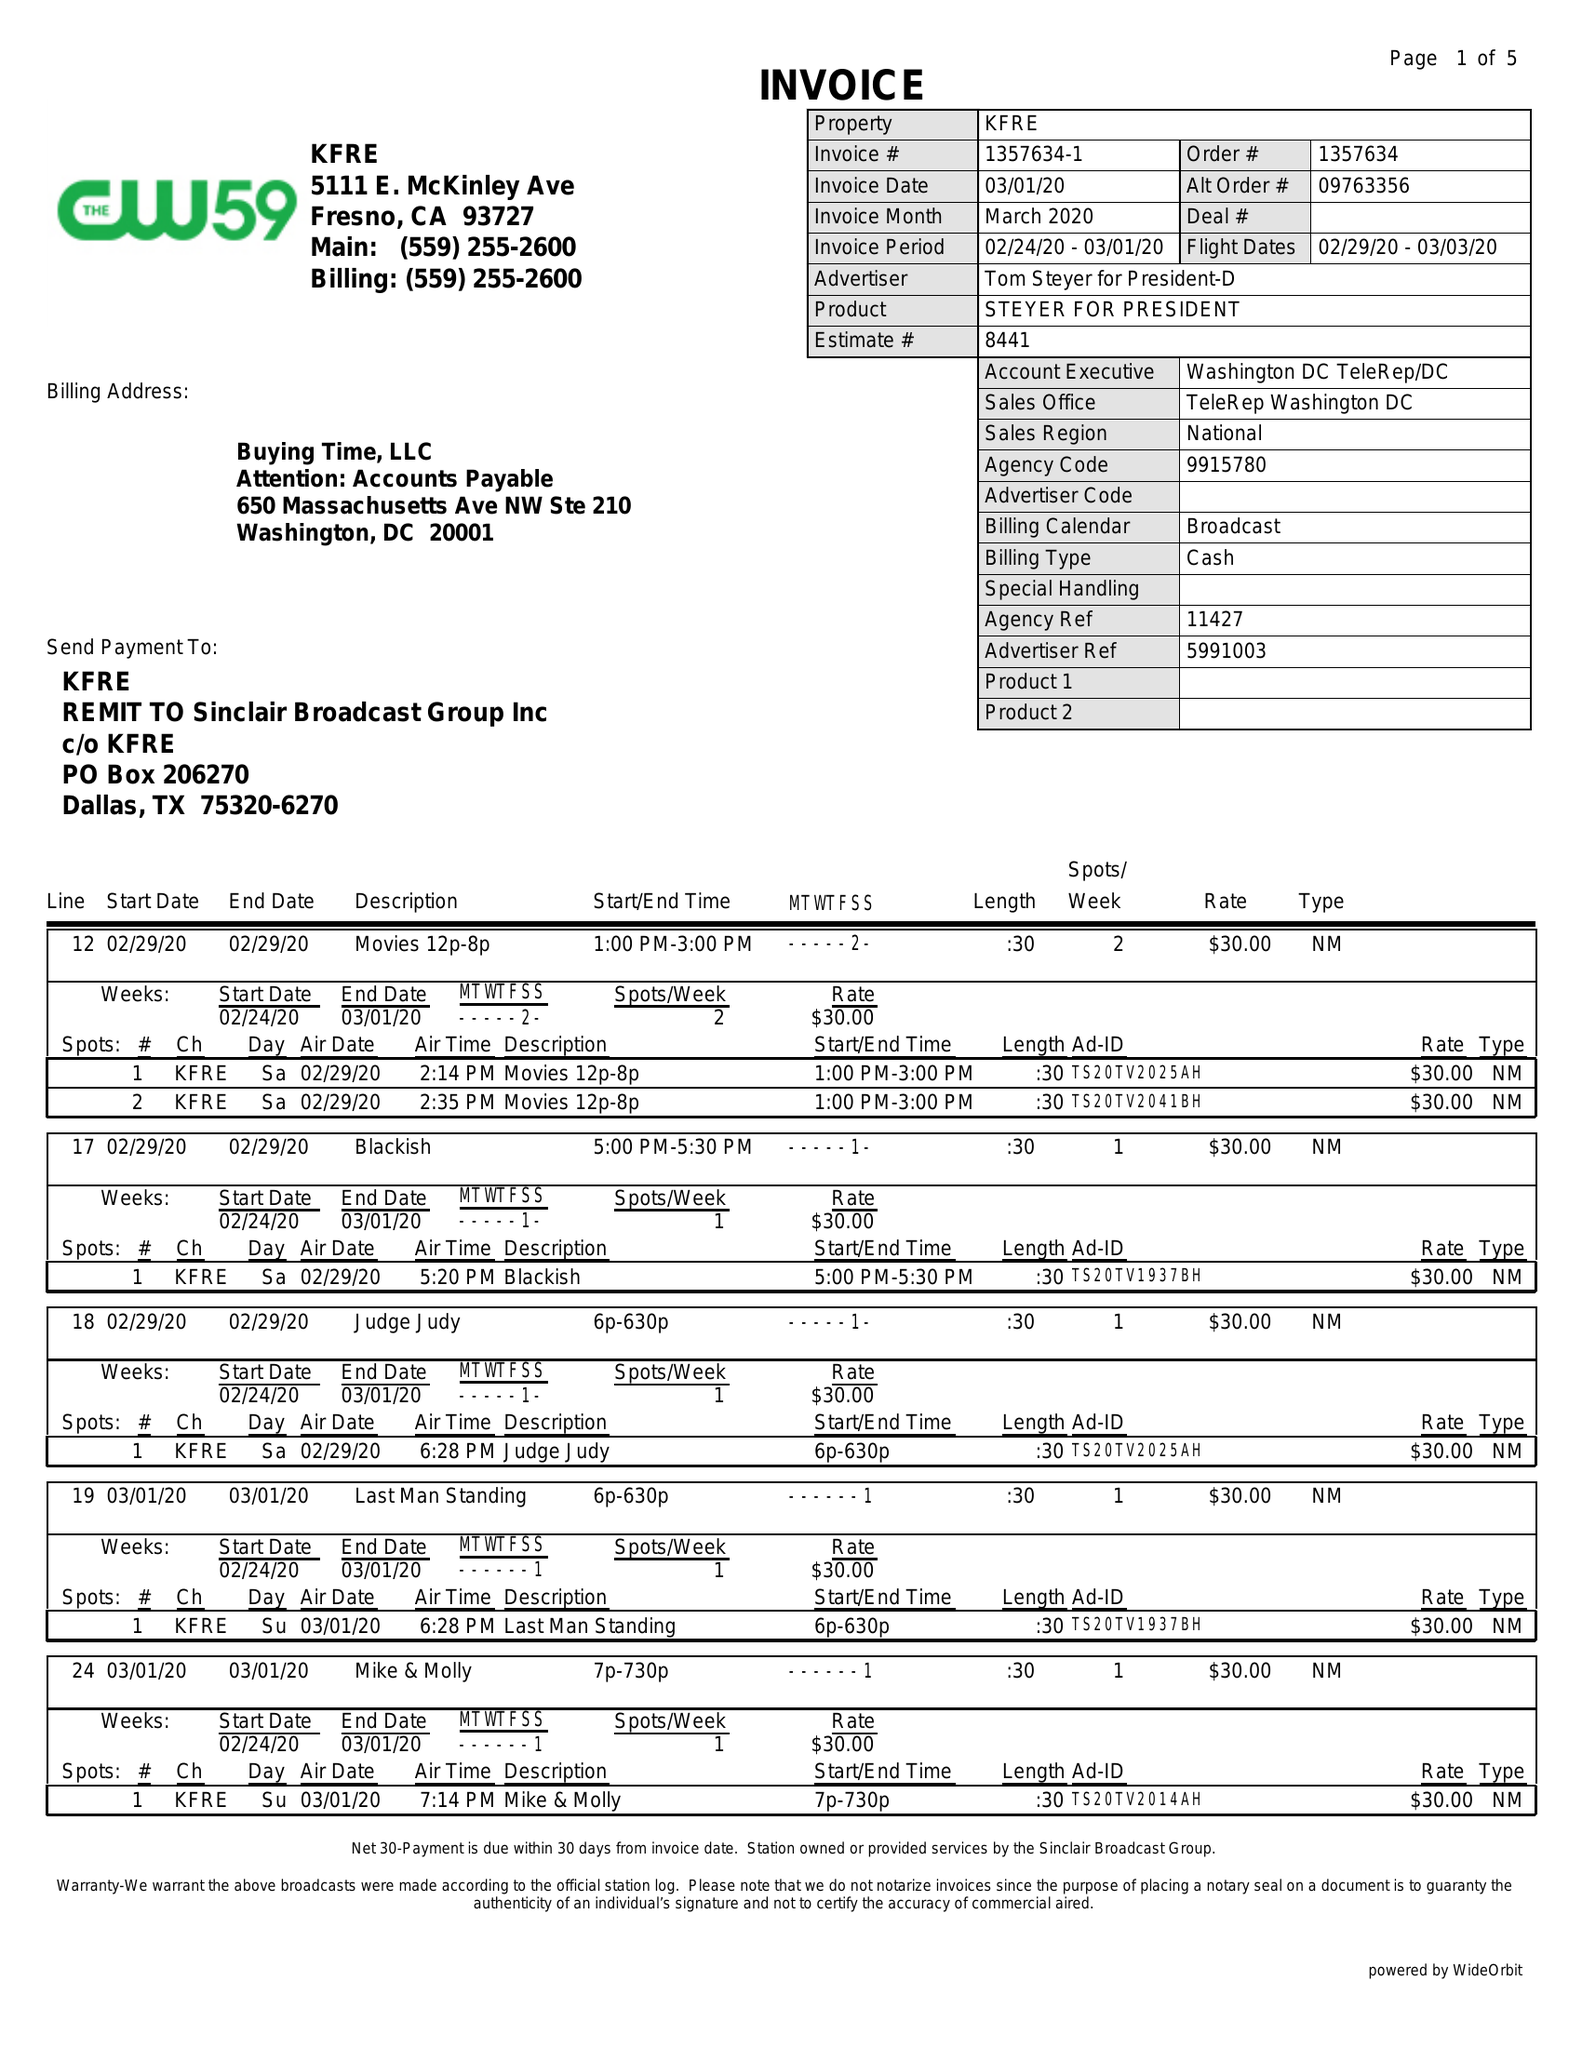What is the value for the contract_num?
Answer the question using a single word or phrase. 1357634 